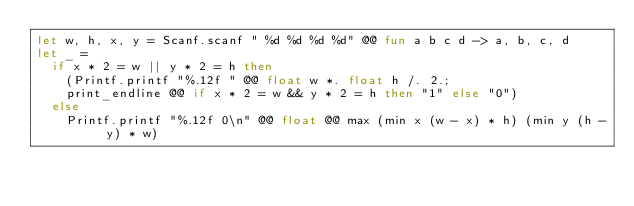Convert code to text. <code><loc_0><loc_0><loc_500><loc_500><_OCaml_>let w, h, x, y = Scanf.scanf " %d %d %d %d" @@ fun a b c d -> a, b, c, d
let _ =
  if x * 2 = w || y * 2 = h then
    (Printf.printf "%.12f " @@ float w *. float h /. 2.;
    print_endline @@ if x * 2 = w && y * 2 = h then "1" else "0")
  else
    Printf.printf "%.12f 0\n" @@ float @@ max (min x (w - x) * h) (min y (h - y) * w)</code> 